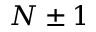<formula> <loc_0><loc_0><loc_500><loc_500>N \pm 1</formula> 